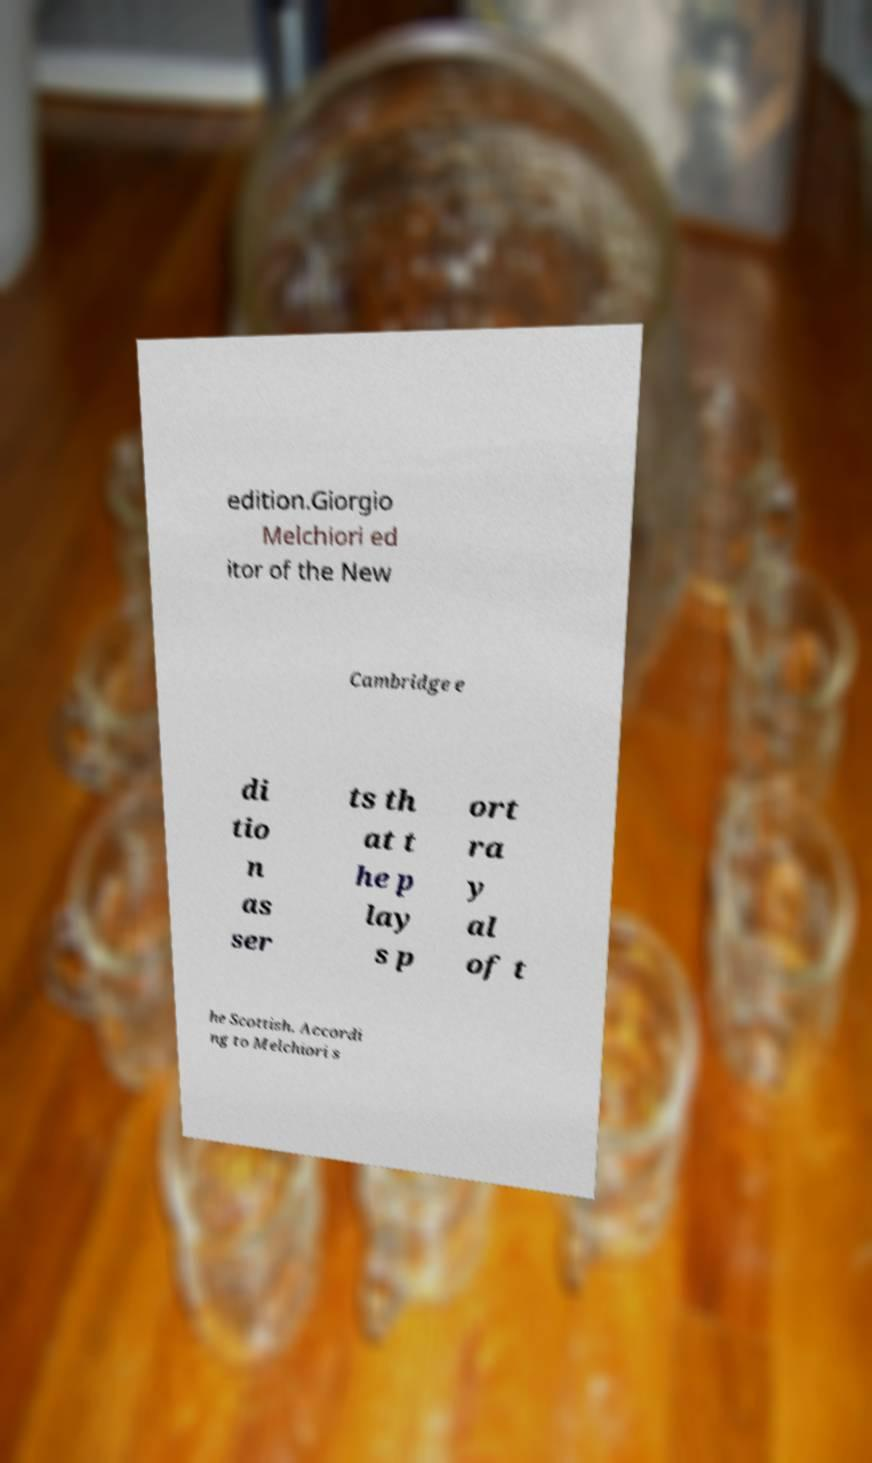Can you accurately transcribe the text from the provided image for me? edition.Giorgio Melchiori ed itor of the New Cambridge e di tio n as ser ts th at t he p lay s p ort ra y al of t he Scottish. Accordi ng to Melchiori s 